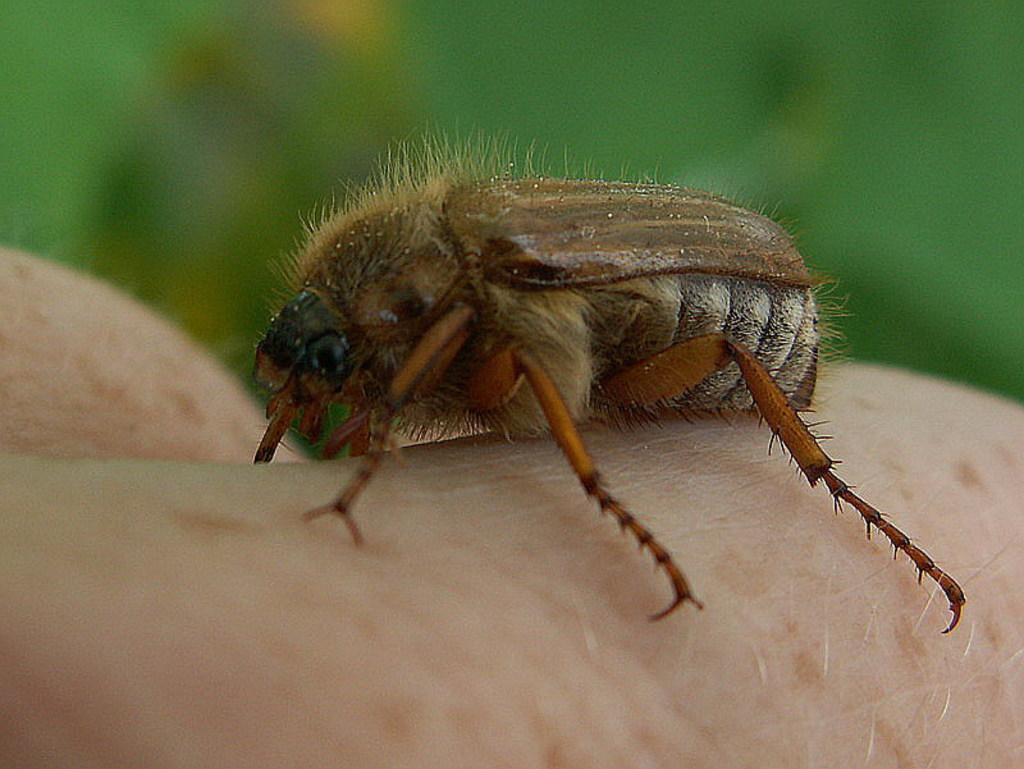Describe this image in one or two sentences. In this image we can see an insect on a hand of a person. 